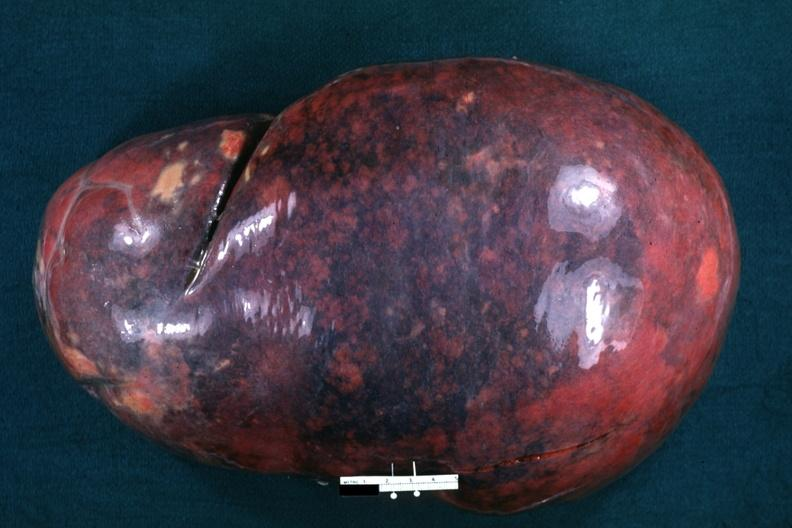s hemochromatosis present?
Answer the question using a single word or phrase. No 